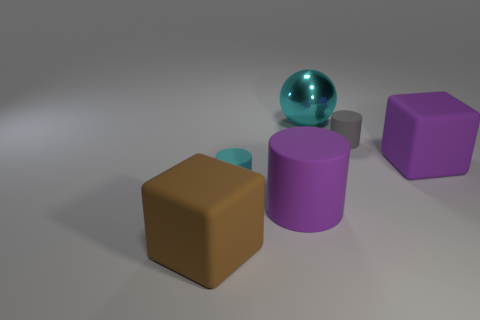Add 2 large cyan spheres. How many objects exist? 8 Subtract all cubes. How many objects are left? 4 Add 5 cyan rubber objects. How many cyan rubber objects are left? 6 Add 1 green rubber blocks. How many green rubber blocks exist? 1 Subtract 0 green balls. How many objects are left? 6 Subtract all brown rubber cubes. Subtract all shiny cubes. How many objects are left? 5 